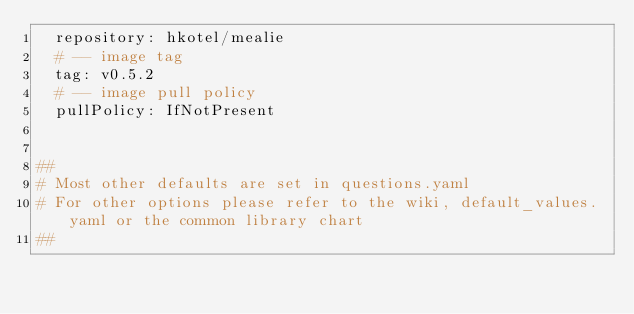Convert code to text. <code><loc_0><loc_0><loc_500><loc_500><_YAML_>  repository: hkotel/mealie
  # -- image tag
  tag: v0.5.2
  # -- image pull policy
  pullPolicy: IfNotPresent


##
# Most other defaults are set in questions.yaml
# For other options please refer to the wiki, default_values.yaml or the common library chart
##
</code> 